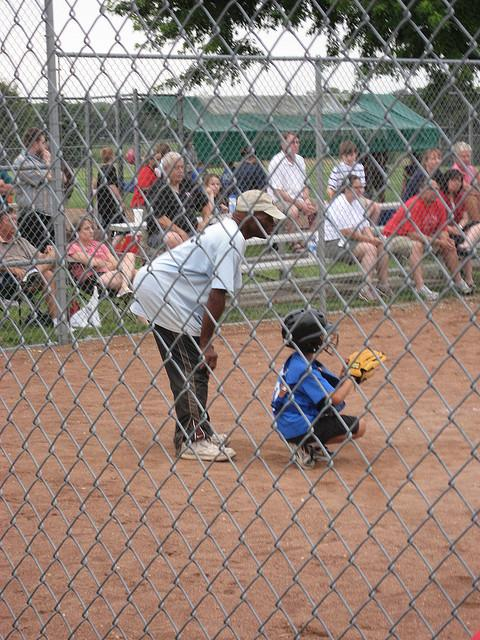How are the people in the stands here likely related to the players on the field here?

Choices:
A) unrelated fans
B) passersby
C) relatives
D) enemies relatives 